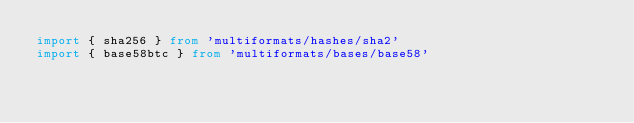<code> <loc_0><loc_0><loc_500><loc_500><_TypeScript_>import { sha256 } from 'multiformats/hashes/sha2'
import { base58btc } from 'multiformats/bases/base58'</code> 